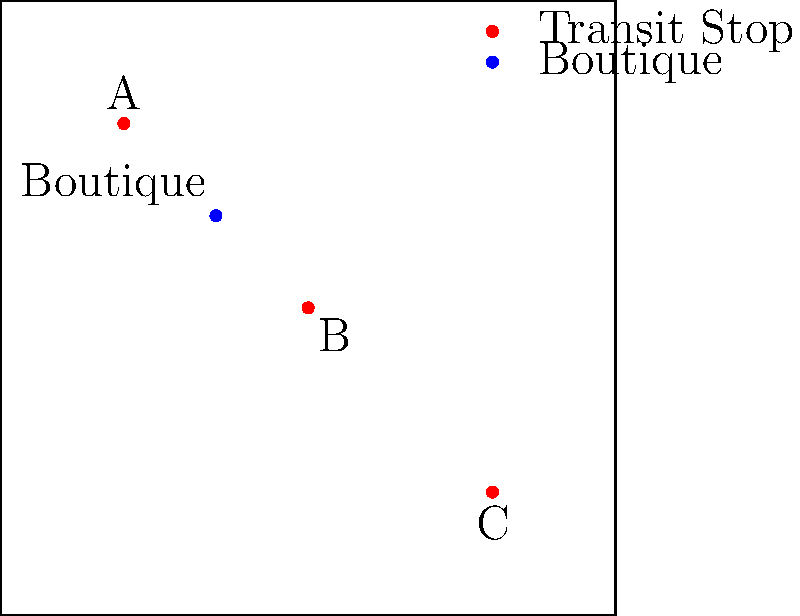Based on the city transit map provided, which transit stop is likely to generate the highest foot traffic for your boutique store? Assume that foot traffic decreases linearly with distance from each transit stop. To determine which transit stop is likely to generate the highest foot traffic for the boutique store, we need to consider the distance between each stop and the store. The closer a stop is to the store, the higher the potential foot traffic it will generate. Let's analyze each stop:

1. Calculate the approximate distances:
   - Stop A to Boutique: $\sqrt{(35-20)^2 + (65-80)^2} \approx 18.03$ units
   - Stop B to Boutique: $\sqrt{(50-35)^2 + (50-65)^2} \approx 21.21$ units
   - Stop C to Boutique: $\sqrt{(80-35)^2 + (20-65)^2} \approx 63.25$ units

2. Compare the distances:
   - Stop A is the closest at approximately 18.03 units.
   - Stop B is slightly farther at approximately 21.21 units.
   - Stop C is significantly farther at approximately 63.25 units.

3. Consider the linear decrease in foot traffic:
   Since foot traffic decreases linearly with distance, the closest stop will generate the highest foot traffic for the boutique.

Therefore, Transit Stop A is likely to generate the highest foot traffic for the boutique store due to its proximity.
Answer: Transit Stop A 